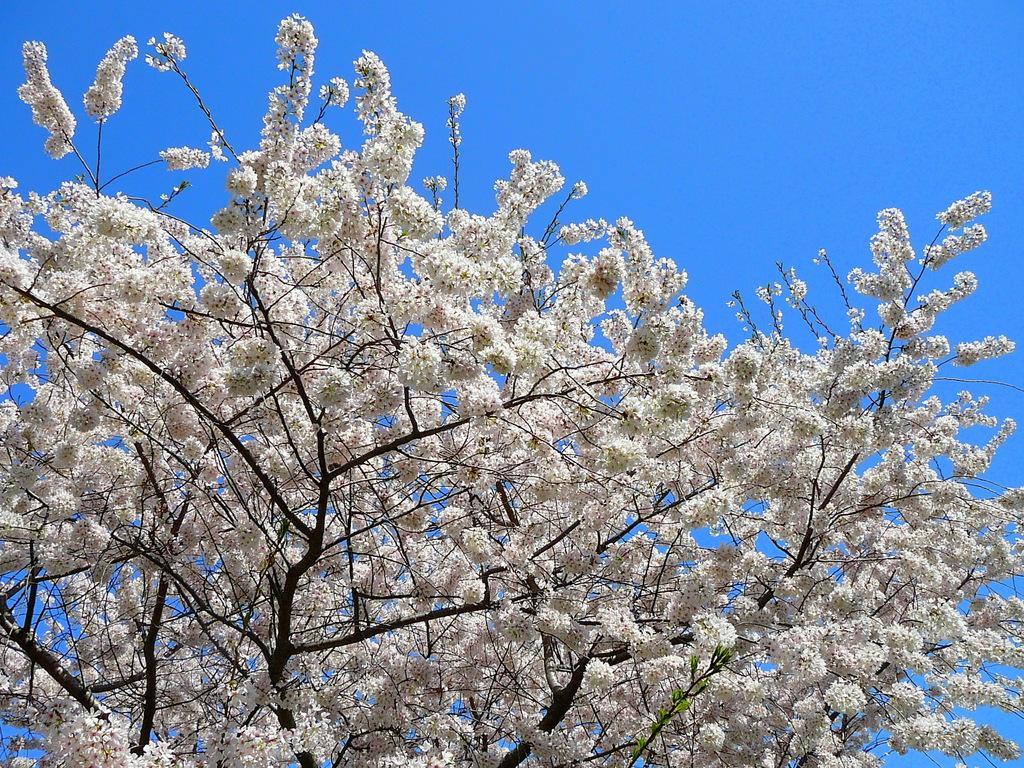Can you describe this image briefly? In this picture there are flower on the tree in the center of the image and the flowers are white in color. 